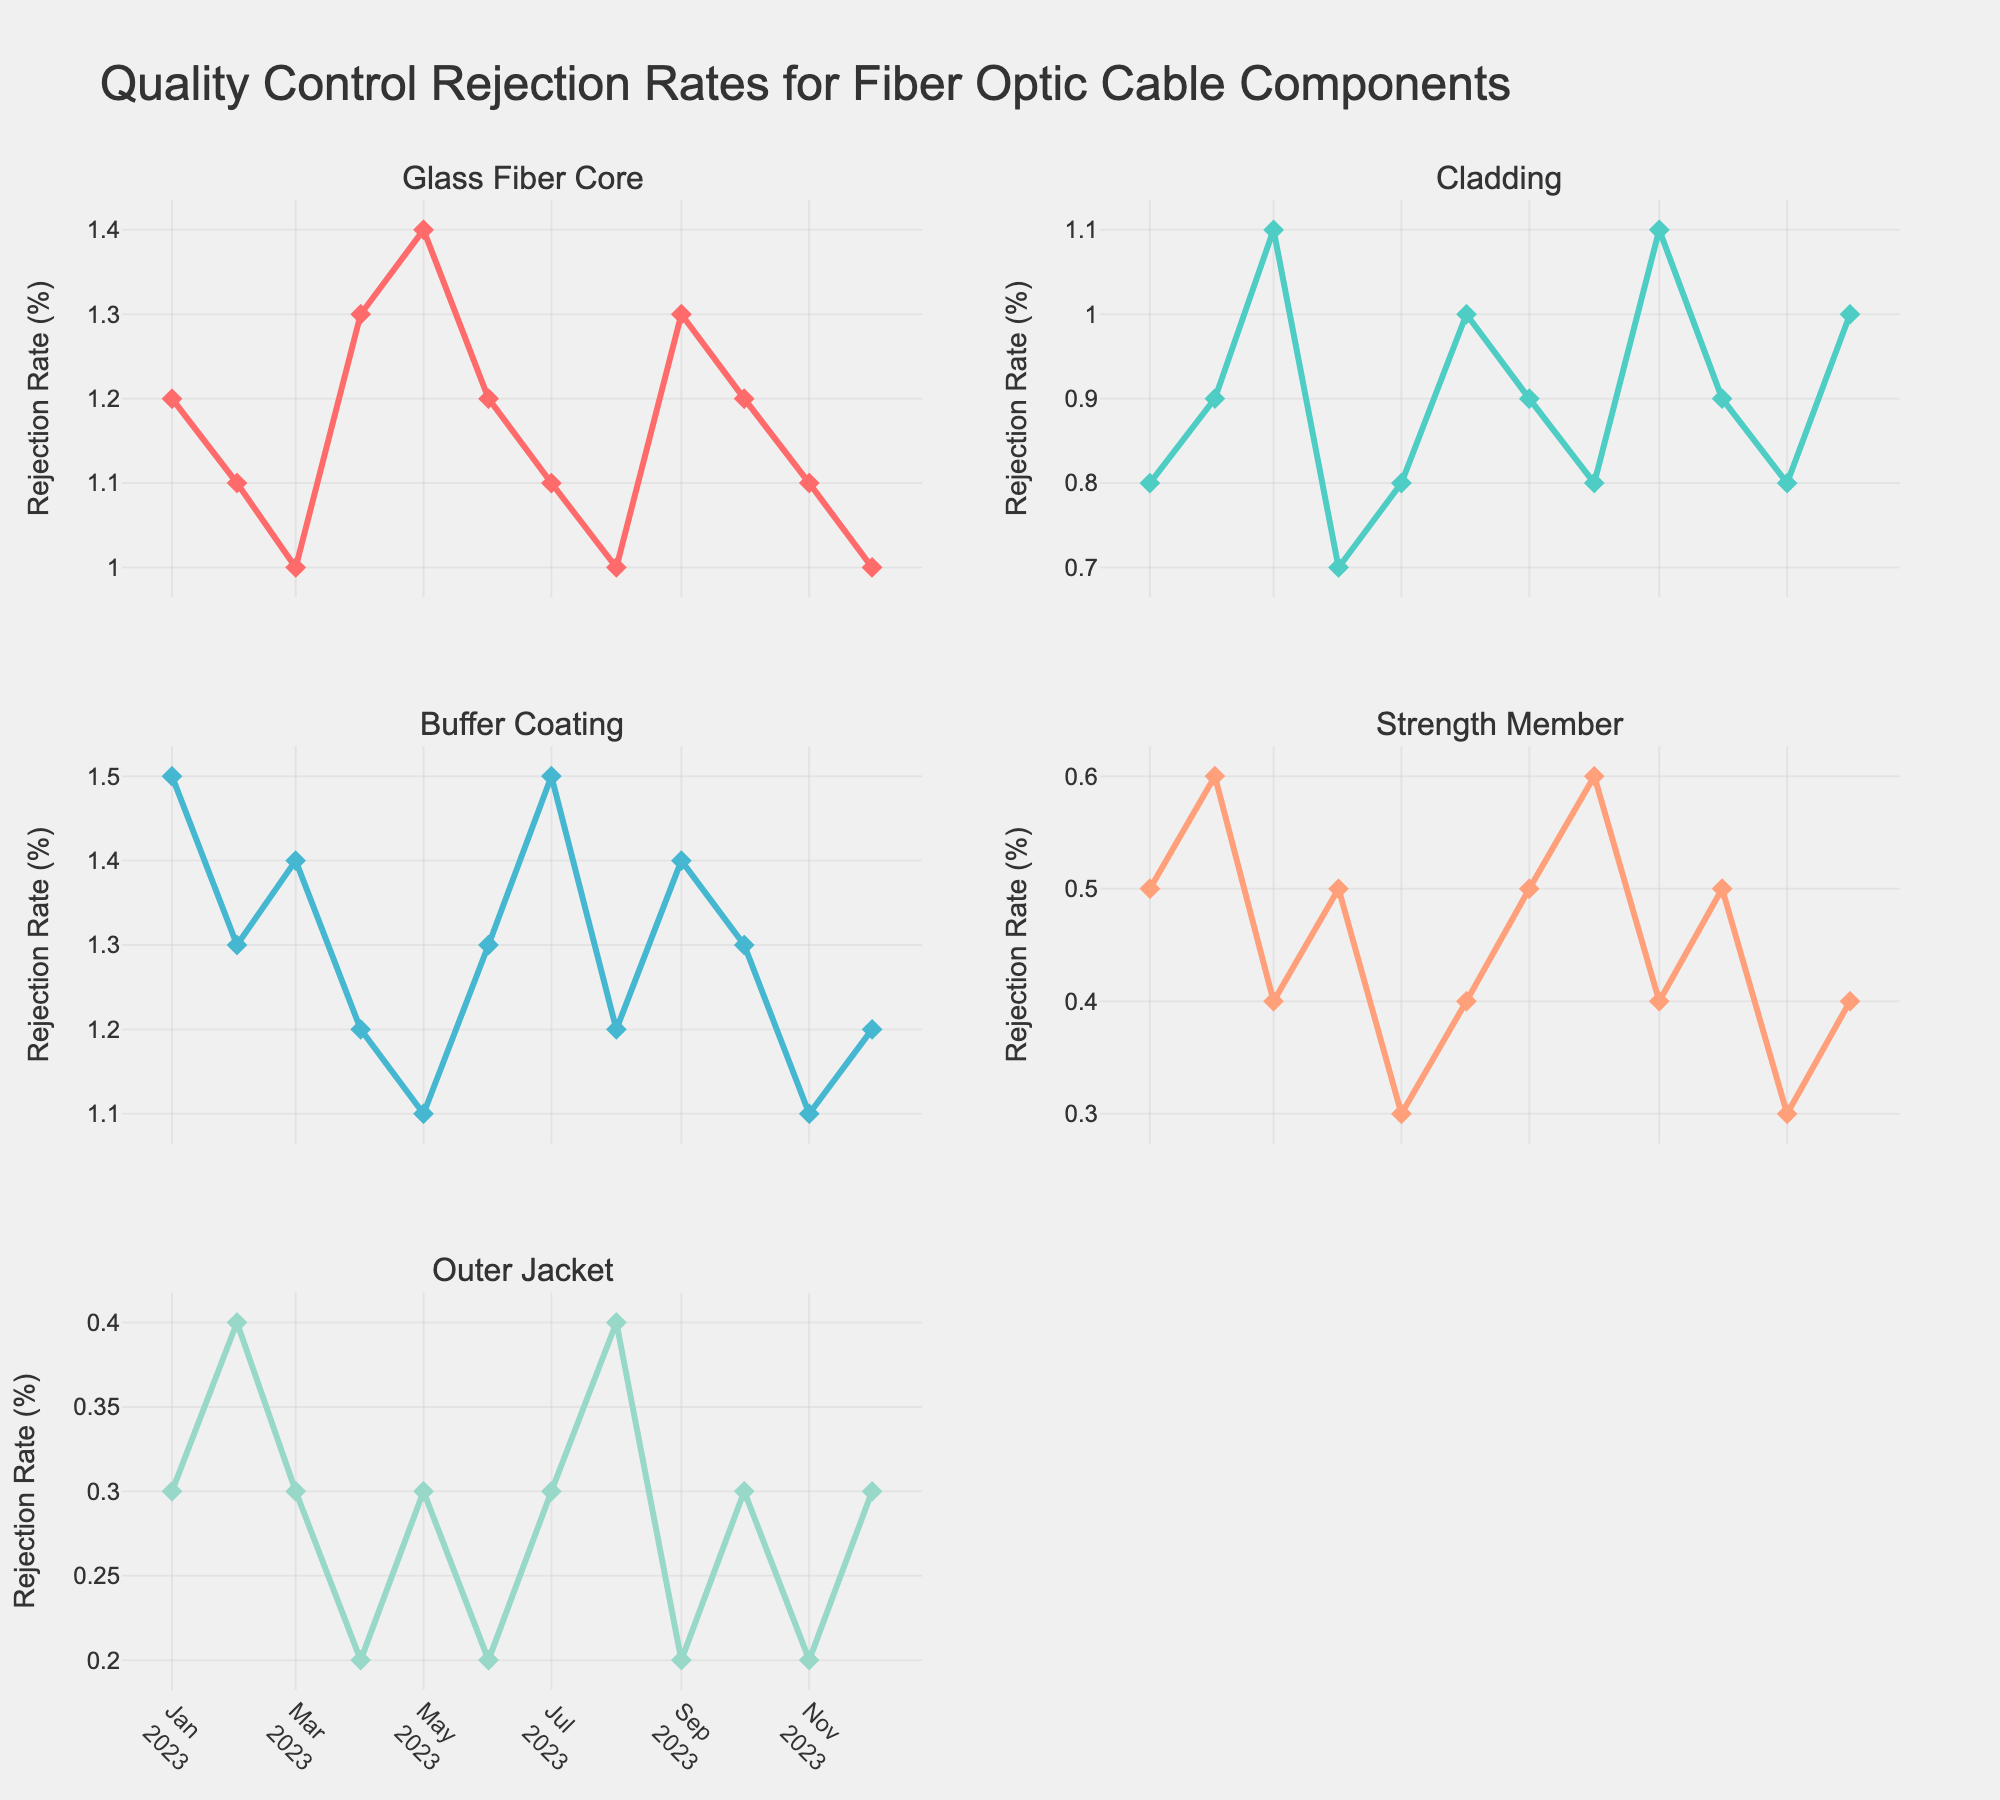What is the title of the figure? The title is placed at the top of the figure and reads "Livestock Weight Gain Analysis."
Answer: Livestock Weight Gain Analysis Which cattle breed has the highest weight gain at 10 hours of grazing time? To find this, look at the plot of "Weight Gain vs Grazing Time" and observe the data points corresponding to 10 hours. Among them, Charolais shows the highest weight gain.
Answer: Charolais How does pasture quality score impact weight gain for the Simmental breed? Observe the subplot "Weight Gain vs Pasture Quality" for Simmental. The points show a trend where as the pasture quality score increases, the weight gain remains relatively low, ranging from 0.4 to 0.7 kg.
Answer: There is a slight increase, but weight gain remains low What is the shape and color of the data points for Limousin in the "Weight Gain vs Grazing Time" subplot? The data points for Limousin in the "Weight Gain vs Grazing Time" subplot are drawn using circle markers and are colored purple.
Answer: Circle, purple Which subplot shows a steeper increase in weight gain for Angus cattle? Compare both subplots for Angus data. In "Weight Gain vs Grazing Time", the increase appears more gradual compared to the "Weight Gain vs Pasture Quality", where the weight gain increases steeply.
Answer: Weight Gain vs Pasture Quality What is the average weight gain for Hereford cattle at different grazing times? Calculate the average by adding the weight gains at 6, 8, and 10 hours (0.6 + 0.9 + 1.0) and divide by 3. (0.6 + 0.9 + 1.0) / 3 = 2.5 / 3 = 0.83
Answer: 0.83 kg For which pasture quality score do Charolais cattle have the most significant weight gain? Look at the subplot "Weight Gain vs Pasture Quality" for Charolais. The highest weight gain corresponds to the pasture quality score of 9.
Answer: 9 Comparing Angus and Limousin, which breed shows higher weight gain on average for the same pasture quality score? Check the "Weight Gain vs Pasture Quality" subplot values for both breeds, then compute average weight gain for each. Angus and Limousin respectively show averages that can be compared.
Answer: Limousin If you were to rank the breeds by their weight gain at 8 hours of grazing time, what would be the order? Review the "Weight Gain vs Grazing Time" subplot for values at 8 hours, then rank: Charolais (1.4), Limousin (1.2), Angus (1.1), Hereford (0.9), Simmental (0.6).
Answer: Charolais, Limousin, Angus, Hereford, Simmental 